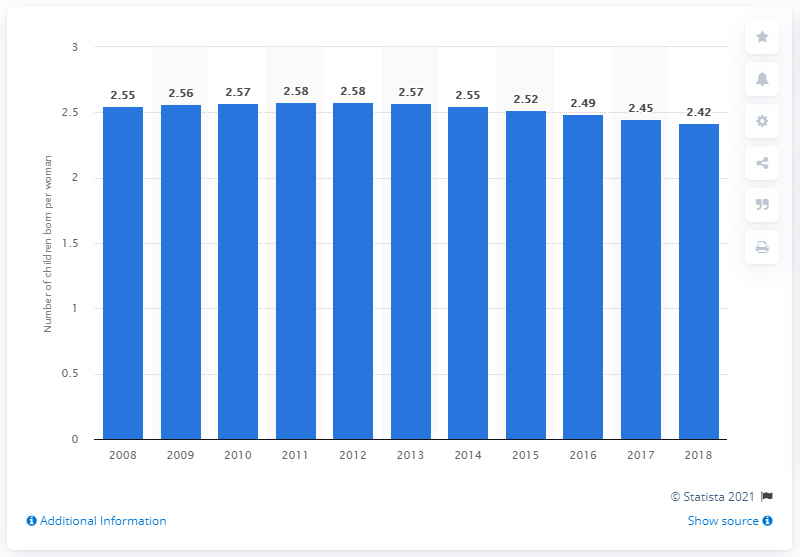Give some essential details in this illustration. In 2018, the fertility rate in Morocco was 2.42. 